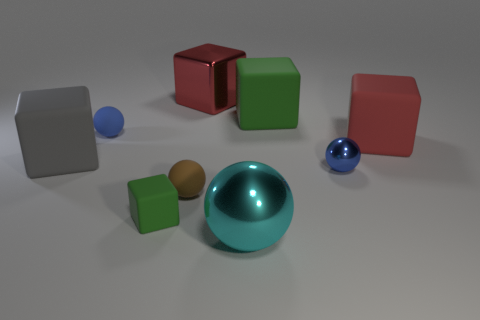Can you guess the materials of the different objects based on their textures? Certainly! The sphere in the foreground has a smooth, shiny surface that suggests it could be made of polished metal or glass. The boxes have a matte finish, indicating a more diffuse reflection which is consistent with a painted or plastic surface. The brown object looks like it could be made from a natural material, possibly wood, since its texture appears more organic and less uniform. 